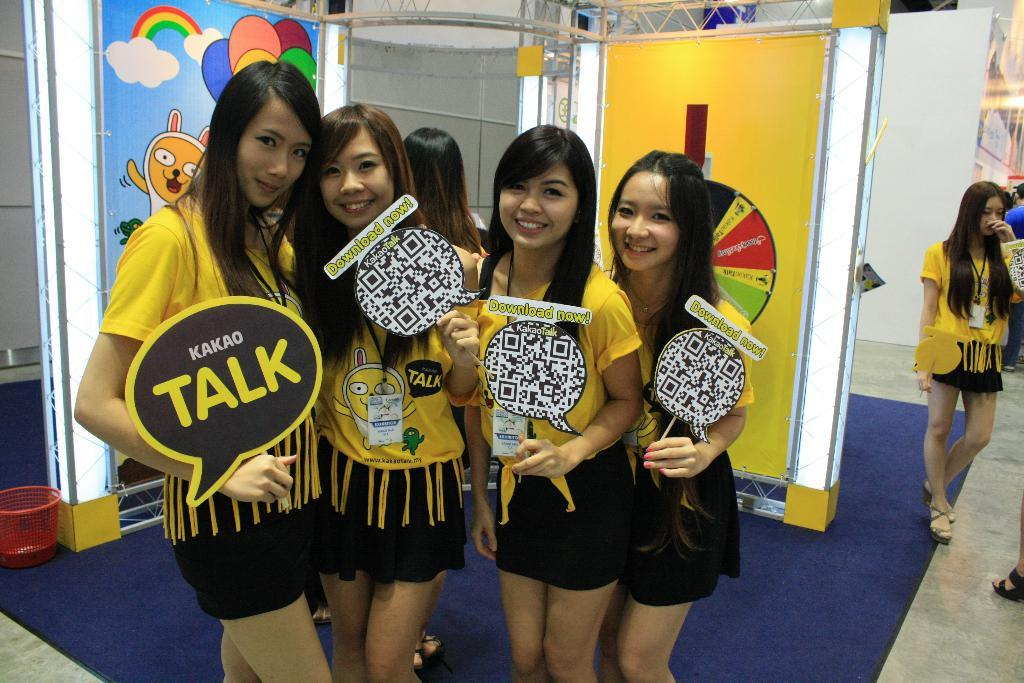<image>
Provide a brief description of the given image. Four girls dressed in yellow and black with four signs in front of them with one of the sign has the word talk on it. 